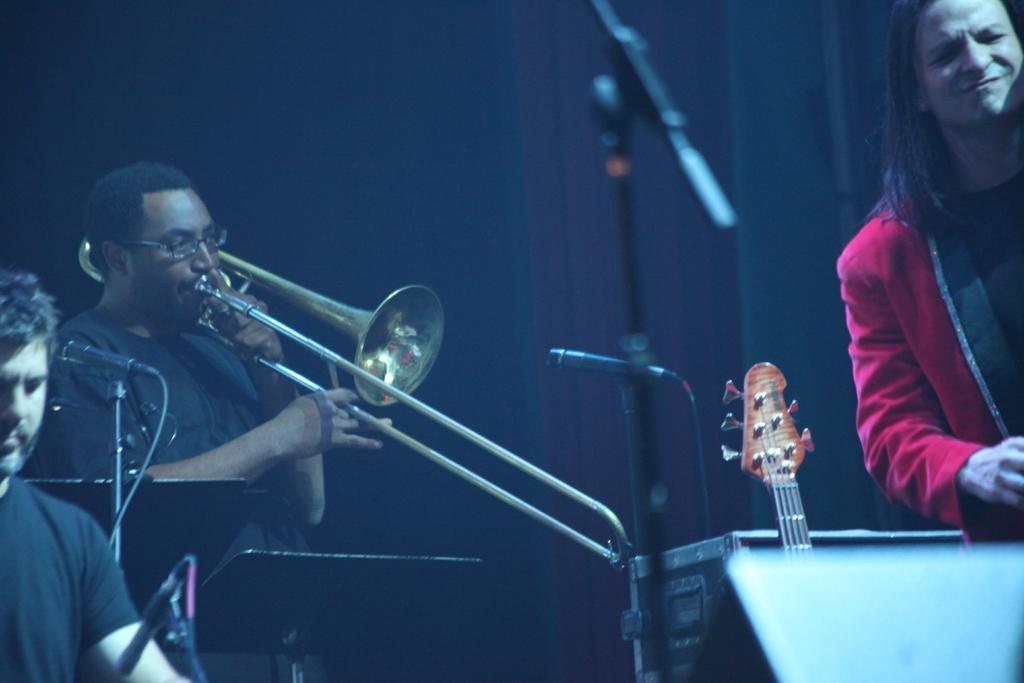Please provide a concise description of this image. There are three musicians performing at the stage in this image. The person at the right side wearing a red colour suit is giving some expressions in his face. The person on the left side is playing musical instrument. And the man at the bottom left wearing black colour t-shirt is seeing at the mic which is in front of him. In the center there is a mic stand and musical instrument. In the background there is black colour sheet. 